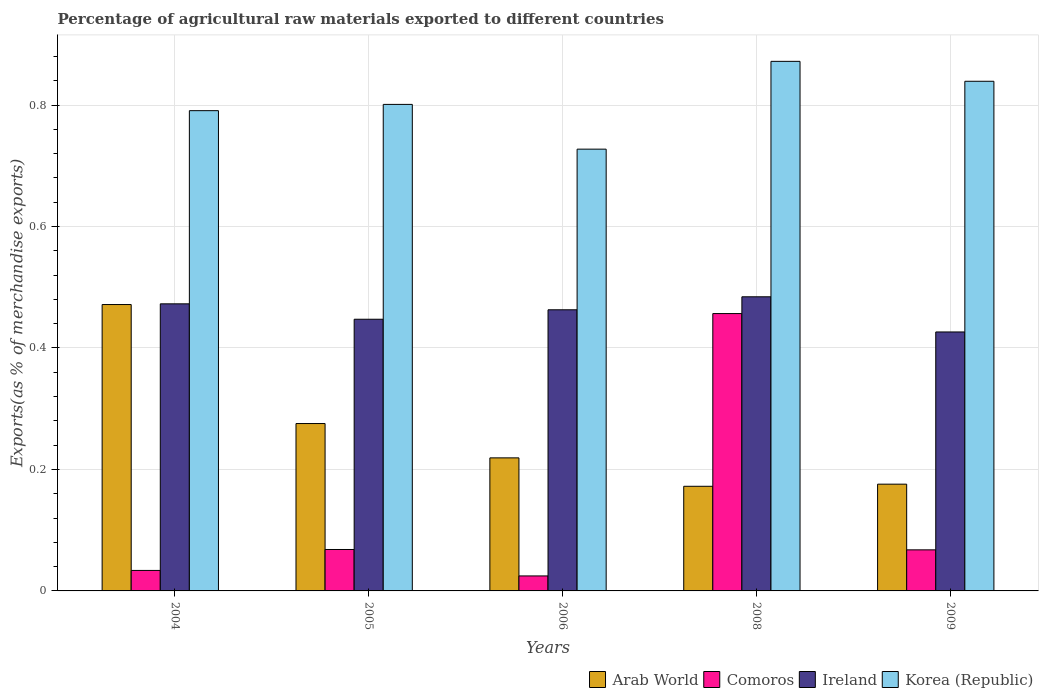How many groups of bars are there?
Give a very brief answer. 5. Are the number of bars on each tick of the X-axis equal?
Offer a terse response. Yes. How many bars are there on the 2nd tick from the left?
Ensure brevity in your answer.  4. What is the label of the 1st group of bars from the left?
Make the answer very short. 2004. What is the percentage of exports to different countries in Arab World in 2005?
Make the answer very short. 0.28. Across all years, what is the maximum percentage of exports to different countries in Ireland?
Offer a very short reply. 0.48. Across all years, what is the minimum percentage of exports to different countries in Korea (Republic)?
Your response must be concise. 0.73. What is the total percentage of exports to different countries in Arab World in the graph?
Give a very brief answer. 1.31. What is the difference between the percentage of exports to different countries in Ireland in 2004 and that in 2005?
Keep it short and to the point. 0.03. What is the difference between the percentage of exports to different countries in Ireland in 2008 and the percentage of exports to different countries in Korea (Republic) in 2009?
Your answer should be very brief. -0.35. What is the average percentage of exports to different countries in Comoros per year?
Your answer should be very brief. 0.13. In the year 2009, what is the difference between the percentage of exports to different countries in Ireland and percentage of exports to different countries in Comoros?
Provide a succinct answer. 0.36. In how many years, is the percentage of exports to different countries in Ireland greater than 0.6400000000000001 %?
Your answer should be compact. 0. What is the ratio of the percentage of exports to different countries in Korea (Republic) in 2005 to that in 2008?
Make the answer very short. 0.92. What is the difference between the highest and the second highest percentage of exports to different countries in Ireland?
Your answer should be compact. 0.01. What is the difference between the highest and the lowest percentage of exports to different countries in Comoros?
Your answer should be very brief. 0.43. In how many years, is the percentage of exports to different countries in Ireland greater than the average percentage of exports to different countries in Ireland taken over all years?
Make the answer very short. 3. What does the 1st bar from the left in 2006 represents?
Offer a very short reply. Arab World. What does the 2nd bar from the right in 2005 represents?
Give a very brief answer. Ireland. How many years are there in the graph?
Provide a succinct answer. 5. Are the values on the major ticks of Y-axis written in scientific E-notation?
Keep it short and to the point. No. Does the graph contain any zero values?
Make the answer very short. No. Does the graph contain grids?
Provide a short and direct response. Yes. How many legend labels are there?
Ensure brevity in your answer.  4. What is the title of the graph?
Your response must be concise. Percentage of agricultural raw materials exported to different countries. What is the label or title of the X-axis?
Your answer should be compact. Years. What is the label or title of the Y-axis?
Your response must be concise. Exports(as % of merchandise exports). What is the Exports(as % of merchandise exports) of Arab World in 2004?
Keep it short and to the point. 0.47. What is the Exports(as % of merchandise exports) of Comoros in 2004?
Provide a short and direct response. 0.03. What is the Exports(as % of merchandise exports) of Ireland in 2004?
Your response must be concise. 0.47. What is the Exports(as % of merchandise exports) of Korea (Republic) in 2004?
Your answer should be compact. 0.79. What is the Exports(as % of merchandise exports) of Arab World in 2005?
Provide a short and direct response. 0.28. What is the Exports(as % of merchandise exports) in Comoros in 2005?
Keep it short and to the point. 0.07. What is the Exports(as % of merchandise exports) of Ireland in 2005?
Ensure brevity in your answer.  0.45. What is the Exports(as % of merchandise exports) in Korea (Republic) in 2005?
Make the answer very short. 0.8. What is the Exports(as % of merchandise exports) of Arab World in 2006?
Ensure brevity in your answer.  0.22. What is the Exports(as % of merchandise exports) of Comoros in 2006?
Your answer should be compact. 0.02. What is the Exports(as % of merchandise exports) of Ireland in 2006?
Your answer should be compact. 0.46. What is the Exports(as % of merchandise exports) in Korea (Republic) in 2006?
Offer a terse response. 0.73. What is the Exports(as % of merchandise exports) of Arab World in 2008?
Provide a short and direct response. 0.17. What is the Exports(as % of merchandise exports) of Comoros in 2008?
Offer a very short reply. 0.46. What is the Exports(as % of merchandise exports) of Ireland in 2008?
Give a very brief answer. 0.48. What is the Exports(as % of merchandise exports) of Korea (Republic) in 2008?
Ensure brevity in your answer.  0.87. What is the Exports(as % of merchandise exports) in Arab World in 2009?
Provide a succinct answer. 0.18. What is the Exports(as % of merchandise exports) in Comoros in 2009?
Provide a succinct answer. 0.07. What is the Exports(as % of merchandise exports) in Ireland in 2009?
Your response must be concise. 0.43. What is the Exports(as % of merchandise exports) in Korea (Republic) in 2009?
Make the answer very short. 0.84. Across all years, what is the maximum Exports(as % of merchandise exports) of Arab World?
Your response must be concise. 0.47. Across all years, what is the maximum Exports(as % of merchandise exports) of Comoros?
Provide a succinct answer. 0.46. Across all years, what is the maximum Exports(as % of merchandise exports) in Ireland?
Ensure brevity in your answer.  0.48. Across all years, what is the maximum Exports(as % of merchandise exports) in Korea (Republic)?
Keep it short and to the point. 0.87. Across all years, what is the minimum Exports(as % of merchandise exports) of Arab World?
Make the answer very short. 0.17. Across all years, what is the minimum Exports(as % of merchandise exports) in Comoros?
Keep it short and to the point. 0.02. Across all years, what is the minimum Exports(as % of merchandise exports) in Ireland?
Give a very brief answer. 0.43. Across all years, what is the minimum Exports(as % of merchandise exports) of Korea (Republic)?
Keep it short and to the point. 0.73. What is the total Exports(as % of merchandise exports) in Arab World in the graph?
Keep it short and to the point. 1.31. What is the total Exports(as % of merchandise exports) in Comoros in the graph?
Your answer should be compact. 0.65. What is the total Exports(as % of merchandise exports) in Ireland in the graph?
Your answer should be very brief. 2.29. What is the total Exports(as % of merchandise exports) in Korea (Republic) in the graph?
Ensure brevity in your answer.  4.03. What is the difference between the Exports(as % of merchandise exports) in Arab World in 2004 and that in 2005?
Ensure brevity in your answer.  0.2. What is the difference between the Exports(as % of merchandise exports) of Comoros in 2004 and that in 2005?
Offer a terse response. -0.03. What is the difference between the Exports(as % of merchandise exports) in Ireland in 2004 and that in 2005?
Your answer should be compact. 0.03. What is the difference between the Exports(as % of merchandise exports) of Korea (Republic) in 2004 and that in 2005?
Your answer should be compact. -0.01. What is the difference between the Exports(as % of merchandise exports) in Arab World in 2004 and that in 2006?
Provide a short and direct response. 0.25. What is the difference between the Exports(as % of merchandise exports) of Comoros in 2004 and that in 2006?
Your answer should be very brief. 0.01. What is the difference between the Exports(as % of merchandise exports) of Ireland in 2004 and that in 2006?
Provide a short and direct response. 0.01. What is the difference between the Exports(as % of merchandise exports) in Korea (Republic) in 2004 and that in 2006?
Keep it short and to the point. 0.06. What is the difference between the Exports(as % of merchandise exports) in Arab World in 2004 and that in 2008?
Provide a short and direct response. 0.3. What is the difference between the Exports(as % of merchandise exports) in Comoros in 2004 and that in 2008?
Your answer should be compact. -0.42. What is the difference between the Exports(as % of merchandise exports) of Ireland in 2004 and that in 2008?
Give a very brief answer. -0.01. What is the difference between the Exports(as % of merchandise exports) of Korea (Republic) in 2004 and that in 2008?
Your answer should be compact. -0.08. What is the difference between the Exports(as % of merchandise exports) of Arab World in 2004 and that in 2009?
Your answer should be compact. 0.3. What is the difference between the Exports(as % of merchandise exports) of Comoros in 2004 and that in 2009?
Your response must be concise. -0.03. What is the difference between the Exports(as % of merchandise exports) in Ireland in 2004 and that in 2009?
Provide a succinct answer. 0.05. What is the difference between the Exports(as % of merchandise exports) in Korea (Republic) in 2004 and that in 2009?
Provide a succinct answer. -0.05. What is the difference between the Exports(as % of merchandise exports) in Arab World in 2005 and that in 2006?
Your answer should be compact. 0.06. What is the difference between the Exports(as % of merchandise exports) of Comoros in 2005 and that in 2006?
Make the answer very short. 0.04. What is the difference between the Exports(as % of merchandise exports) of Ireland in 2005 and that in 2006?
Offer a terse response. -0.02. What is the difference between the Exports(as % of merchandise exports) in Korea (Republic) in 2005 and that in 2006?
Offer a very short reply. 0.07. What is the difference between the Exports(as % of merchandise exports) in Arab World in 2005 and that in 2008?
Provide a short and direct response. 0.1. What is the difference between the Exports(as % of merchandise exports) in Comoros in 2005 and that in 2008?
Your answer should be compact. -0.39. What is the difference between the Exports(as % of merchandise exports) in Ireland in 2005 and that in 2008?
Provide a succinct answer. -0.04. What is the difference between the Exports(as % of merchandise exports) in Korea (Republic) in 2005 and that in 2008?
Provide a short and direct response. -0.07. What is the difference between the Exports(as % of merchandise exports) of Arab World in 2005 and that in 2009?
Ensure brevity in your answer.  0.1. What is the difference between the Exports(as % of merchandise exports) in Comoros in 2005 and that in 2009?
Ensure brevity in your answer.  0. What is the difference between the Exports(as % of merchandise exports) in Ireland in 2005 and that in 2009?
Your response must be concise. 0.02. What is the difference between the Exports(as % of merchandise exports) of Korea (Republic) in 2005 and that in 2009?
Provide a short and direct response. -0.04. What is the difference between the Exports(as % of merchandise exports) of Arab World in 2006 and that in 2008?
Ensure brevity in your answer.  0.05. What is the difference between the Exports(as % of merchandise exports) of Comoros in 2006 and that in 2008?
Your answer should be compact. -0.43. What is the difference between the Exports(as % of merchandise exports) in Ireland in 2006 and that in 2008?
Give a very brief answer. -0.02. What is the difference between the Exports(as % of merchandise exports) in Korea (Republic) in 2006 and that in 2008?
Provide a short and direct response. -0.14. What is the difference between the Exports(as % of merchandise exports) in Arab World in 2006 and that in 2009?
Provide a short and direct response. 0.04. What is the difference between the Exports(as % of merchandise exports) of Comoros in 2006 and that in 2009?
Your answer should be compact. -0.04. What is the difference between the Exports(as % of merchandise exports) in Ireland in 2006 and that in 2009?
Your response must be concise. 0.04. What is the difference between the Exports(as % of merchandise exports) of Korea (Republic) in 2006 and that in 2009?
Your answer should be compact. -0.11. What is the difference between the Exports(as % of merchandise exports) of Arab World in 2008 and that in 2009?
Provide a succinct answer. -0. What is the difference between the Exports(as % of merchandise exports) of Comoros in 2008 and that in 2009?
Your response must be concise. 0.39. What is the difference between the Exports(as % of merchandise exports) in Ireland in 2008 and that in 2009?
Give a very brief answer. 0.06. What is the difference between the Exports(as % of merchandise exports) in Korea (Republic) in 2008 and that in 2009?
Your answer should be very brief. 0.03. What is the difference between the Exports(as % of merchandise exports) in Arab World in 2004 and the Exports(as % of merchandise exports) in Comoros in 2005?
Keep it short and to the point. 0.4. What is the difference between the Exports(as % of merchandise exports) in Arab World in 2004 and the Exports(as % of merchandise exports) in Ireland in 2005?
Your answer should be very brief. 0.02. What is the difference between the Exports(as % of merchandise exports) of Arab World in 2004 and the Exports(as % of merchandise exports) of Korea (Republic) in 2005?
Provide a short and direct response. -0.33. What is the difference between the Exports(as % of merchandise exports) of Comoros in 2004 and the Exports(as % of merchandise exports) of Ireland in 2005?
Provide a succinct answer. -0.41. What is the difference between the Exports(as % of merchandise exports) in Comoros in 2004 and the Exports(as % of merchandise exports) in Korea (Republic) in 2005?
Offer a terse response. -0.77. What is the difference between the Exports(as % of merchandise exports) in Ireland in 2004 and the Exports(as % of merchandise exports) in Korea (Republic) in 2005?
Your answer should be compact. -0.33. What is the difference between the Exports(as % of merchandise exports) in Arab World in 2004 and the Exports(as % of merchandise exports) in Comoros in 2006?
Your answer should be compact. 0.45. What is the difference between the Exports(as % of merchandise exports) in Arab World in 2004 and the Exports(as % of merchandise exports) in Ireland in 2006?
Offer a terse response. 0.01. What is the difference between the Exports(as % of merchandise exports) in Arab World in 2004 and the Exports(as % of merchandise exports) in Korea (Republic) in 2006?
Ensure brevity in your answer.  -0.26. What is the difference between the Exports(as % of merchandise exports) of Comoros in 2004 and the Exports(as % of merchandise exports) of Ireland in 2006?
Provide a succinct answer. -0.43. What is the difference between the Exports(as % of merchandise exports) in Comoros in 2004 and the Exports(as % of merchandise exports) in Korea (Republic) in 2006?
Keep it short and to the point. -0.69. What is the difference between the Exports(as % of merchandise exports) of Ireland in 2004 and the Exports(as % of merchandise exports) of Korea (Republic) in 2006?
Provide a short and direct response. -0.25. What is the difference between the Exports(as % of merchandise exports) of Arab World in 2004 and the Exports(as % of merchandise exports) of Comoros in 2008?
Offer a very short reply. 0.01. What is the difference between the Exports(as % of merchandise exports) in Arab World in 2004 and the Exports(as % of merchandise exports) in Ireland in 2008?
Your answer should be compact. -0.01. What is the difference between the Exports(as % of merchandise exports) of Arab World in 2004 and the Exports(as % of merchandise exports) of Korea (Republic) in 2008?
Provide a succinct answer. -0.4. What is the difference between the Exports(as % of merchandise exports) in Comoros in 2004 and the Exports(as % of merchandise exports) in Ireland in 2008?
Your answer should be compact. -0.45. What is the difference between the Exports(as % of merchandise exports) in Comoros in 2004 and the Exports(as % of merchandise exports) in Korea (Republic) in 2008?
Provide a succinct answer. -0.84. What is the difference between the Exports(as % of merchandise exports) of Ireland in 2004 and the Exports(as % of merchandise exports) of Korea (Republic) in 2008?
Ensure brevity in your answer.  -0.4. What is the difference between the Exports(as % of merchandise exports) of Arab World in 2004 and the Exports(as % of merchandise exports) of Comoros in 2009?
Offer a very short reply. 0.4. What is the difference between the Exports(as % of merchandise exports) in Arab World in 2004 and the Exports(as % of merchandise exports) in Ireland in 2009?
Your answer should be very brief. 0.05. What is the difference between the Exports(as % of merchandise exports) of Arab World in 2004 and the Exports(as % of merchandise exports) of Korea (Republic) in 2009?
Offer a terse response. -0.37. What is the difference between the Exports(as % of merchandise exports) in Comoros in 2004 and the Exports(as % of merchandise exports) in Ireland in 2009?
Give a very brief answer. -0.39. What is the difference between the Exports(as % of merchandise exports) of Comoros in 2004 and the Exports(as % of merchandise exports) of Korea (Republic) in 2009?
Give a very brief answer. -0.81. What is the difference between the Exports(as % of merchandise exports) of Ireland in 2004 and the Exports(as % of merchandise exports) of Korea (Republic) in 2009?
Ensure brevity in your answer.  -0.37. What is the difference between the Exports(as % of merchandise exports) in Arab World in 2005 and the Exports(as % of merchandise exports) in Comoros in 2006?
Offer a terse response. 0.25. What is the difference between the Exports(as % of merchandise exports) in Arab World in 2005 and the Exports(as % of merchandise exports) in Ireland in 2006?
Provide a succinct answer. -0.19. What is the difference between the Exports(as % of merchandise exports) in Arab World in 2005 and the Exports(as % of merchandise exports) in Korea (Republic) in 2006?
Your answer should be compact. -0.45. What is the difference between the Exports(as % of merchandise exports) of Comoros in 2005 and the Exports(as % of merchandise exports) of Ireland in 2006?
Your response must be concise. -0.39. What is the difference between the Exports(as % of merchandise exports) of Comoros in 2005 and the Exports(as % of merchandise exports) of Korea (Republic) in 2006?
Give a very brief answer. -0.66. What is the difference between the Exports(as % of merchandise exports) of Ireland in 2005 and the Exports(as % of merchandise exports) of Korea (Republic) in 2006?
Your answer should be very brief. -0.28. What is the difference between the Exports(as % of merchandise exports) in Arab World in 2005 and the Exports(as % of merchandise exports) in Comoros in 2008?
Provide a short and direct response. -0.18. What is the difference between the Exports(as % of merchandise exports) of Arab World in 2005 and the Exports(as % of merchandise exports) of Ireland in 2008?
Give a very brief answer. -0.21. What is the difference between the Exports(as % of merchandise exports) of Arab World in 2005 and the Exports(as % of merchandise exports) of Korea (Republic) in 2008?
Your answer should be very brief. -0.6. What is the difference between the Exports(as % of merchandise exports) in Comoros in 2005 and the Exports(as % of merchandise exports) in Ireland in 2008?
Offer a very short reply. -0.42. What is the difference between the Exports(as % of merchandise exports) in Comoros in 2005 and the Exports(as % of merchandise exports) in Korea (Republic) in 2008?
Your response must be concise. -0.8. What is the difference between the Exports(as % of merchandise exports) of Ireland in 2005 and the Exports(as % of merchandise exports) of Korea (Republic) in 2008?
Offer a very short reply. -0.42. What is the difference between the Exports(as % of merchandise exports) of Arab World in 2005 and the Exports(as % of merchandise exports) of Comoros in 2009?
Provide a short and direct response. 0.21. What is the difference between the Exports(as % of merchandise exports) of Arab World in 2005 and the Exports(as % of merchandise exports) of Ireland in 2009?
Keep it short and to the point. -0.15. What is the difference between the Exports(as % of merchandise exports) of Arab World in 2005 and the Exports(as % of merchandise exports) of Korea (Republic) in 2009?
Give a very brief answer. -0.56. What is the difference between the Exports(as % of merchandise exports) in Comoros in 2005 and the Exports(as % of merchandise exports) in Ireland in 2009?
Give a very brief answer. -0.36. What is the difference between the Exports(as % of merchandise exports) of Comoros in 2005 and the Exports(as % of merchandise exports) of Korea (Republic) in 2009?
Give a very brief answer. -0.77. What is the difference between the Exports(as % of merchandise exports) in Ireland in 2005 and the Exports(as % of merchandise exports) in Korea (Republic) in 2009?
Make the answer very short. -0.39. What is the difference between the Exports(as % of merchandise exports) of Arab World in 2006 and the Exports(as % of merchandise exports) of Comoros in 2008?
Give a very brief answer. -0.24. What is the difference between the Exports(as % of merchandise exports) in Arab World in 2006 and the Exports(as % of merchandise exports) in Ireland in 2008?
Offer a terse response. -0.27. What is the difference between the Exports(as % of merchandise exports) in Arab World in 2006 and the Exports(as % of merchandise exports) in Korea (Republic) in 2008?
Your answer should be compact. -0.65. What is the difference between the Exports(as % of merchandise exports) in Comoros in 2006 and the Exports(as % of merchandise exports) in Ireland in 2008?
Provide a succinct answer. -0.46. What is the difference between the Exports(as % of merchandise exports) in Comoros in 2006 and the Exports(as % of merchandise exports) in Korea (Republic) in 2008?
Give a very brief answer. -0.85. What is the difference between the Exports(as % of merchandise exports) in Ireland in 2006 and the Exports(as % of merchandise exports) in Korea (Republic) in 2008?
Your answer should be very brief. -0.41. What is the difference between the Exports(as % of merchandise exports) in Arab World in 2006 and the Exports(as % of merchandise exports) in Comoros in 2009?
Offer a very short reply. 0.15. What is the difference between the Exports(as % of merchandise exports) of Arab World in 2006 and the Exports(as % of merchandise exports) of Ireland in 2009?
Your answer should be compact. -0.21. What is the difference between the Exports(as % of merchandise exports) of Arab World in 2006 and the Exports(as % of merchandise exports) of Korea (Republic) in 2009?
Keep it short and to the point. -0.62. What is the difference between the Exports(as % of merchandise exports) in Comoros in 2006 and the Exports(as % of merchandise exports) in Ireland in 2009?
Your answer should be very brief. -0.4. What is the difference between the Exports(as % of merchandise exports) in Comoros in 2006 and the Exports(as % of merchandise exports) in Korea (Republic) in 2009?
Offer a terse response. -0.81. What is the difference between the Exports(as % of merchandise exports) of Ireland in 2006 and the Exports(as % of merchandise exports) of Korea (Republic) in 2009?
Provide a short and direct response. -0.38. What is the difference between the Exports(as % of merchandise exports) in Arab World in 2008 and the Exports(as % of merchandise exports) in Comoros in 2009?
Your answer should be compact. 0.1. What is the difference between the Exports(as % of merchandise exports) in Arab World in 2008 and the Exports(as % of merchandise exports) in Ireland in 2009?
Keep it short and to the point. -0.25. What is the difference between the Exports(as % of merchandise exports) in Arab World in 2008 and the Exports(as % of merchandise exports) in Korea (Republic) in 2009?
Provide a short and direct response. -0.67. What is the difference between the Exports(as % of merchandise exports) of Comoros in 2008 and the Exports(as % of merchandise exports) of Ireland in 2009?
Ensure brevity in your answer.  0.03. What is the difference between the Exports(as % of merchandise exports) in Comoros in 2008 and the Exports(as % of merchandise exports) in Korea (Republic) in 2009?
Offer a very short reply. -0.38. What is the difference between the Exports(as % of merchandise exports) in Ireland in 2008 and the Exports(as % of merchandise exports) in Korea (Republic) in 2009?
Your answer should be very brief. -0.35. What is the average Exports(as % of merchandise exports) of Arab World per year?
Your response must be concise. 0.26. What is the average Exports(as % of merchandise exports) of Comoros per year?
Keep it short and to the point. 0.13. What is the average Exports(as % of merchandise exports) in Ireland per year?
Keep it short and to the point. 0.46. What is the average Exports(as % of merchandise exports) in Korea (Republic) per year?
Give a very brief answer. 0.81. In the year 2004, what is the difference between the Exports(as % of merchandise exports) in Arab World and Exports(as % of merchandise exports) in Comoros?
Give a very brief answer. 0.44. In the year 2004, what is the difference between the Exports(as % of merchandise exports) of Arab World and Exports(as % of merchandise exports) of Ireland?
Ensure brevity in your answer.  -0. In the year 2004, what is the difference between the Exports(as % of merchandise exports) in Arab World and Exports(as % of merchandise exports) in Korea (Republic)?
Provide a short and direct response. -0.32. In the year 2004, what is the difference between the Exports(as % of merchandise exports) of Comoros and Exports(as % of merchandise exports) of Ireland?
Ensure brevity in your answer.  -0.44. In the year 2004, what is the difference between the Exports(as % of merchandise exports) in Comoros and Exports(as % of merchandise exports) in Korea (Republic)?
Your answer should be very brief. -0.76. In the year 2004, what is the difference between the Exports(as % of merchandise exports) of Ireland and Exports(as % of merchandise exports) of Korea (Republic)?
Provide a succinct answer. -0.32. In the year 2005, what is the difference between the Exports(as % of merchandise exports) in Arab World and Exports(as % of merchandise exports) in Comoros?
Offer a terse response. 0.21. In the year 2005, what is the difference between the Exports(as % of merchandise exports) in Arab World and Exports(as % of merchandise exports) in Ireland?
Offer a very short reply. -0.17. In the year 2005, what is the difference between the Exports(as % of merchandise exports) of Arab World and Exports(as % of merchandise exports) of Korea (Republic)?
Your answer should be compact. -0.53. In the year 2005, what is the difference between the Exports(as % of merchandise exports) in Comoros and Exports(as % of merchandise exports) in Ireland?
Offer a very short reply. -0.38. In the year 2005, what is the difference between the Exports(as % of merchandise exports) of Comoros and Exports(as % of merchandise exports) of Korea (Republic)?
Provide a succinct answer. -0.73. In the year 2005, what is the difference between the Exports(as % of merchandise exports) in Ireland and Exports(as % of merchandise exports) in Korea (Republic)?
Offer a terse response. -0.35. In the year 2006, what is the difference between the Exports(as % of merchandise exports) of Arab World and Exports(as % of merchandise exports) of Comoros?
Your answer should be compact. 0.19. In the year 2006, what is the difference between the Exports(as % of merchandise exports) in Arab World and Exports(as % of merchandise exports) in Ireland?
Offer a terse response. -0.24. In the year 2006, what is the difference between the Exports(as % of merchandise exports) in Arab World and Exports(as % of merchandise exports) in Korea (Republic)?
Offer a terse response. -0.51. In the year 2006, what is the difference between the Exports(as % of merchandise exports) in Comoros and Exports(as % of merchandise exports) in Ireland?
Offer a very short reply. -0.44. In the year 2006, what is the difference between the Exports(as % of merchandise exports) in Comoros and Exports(as % of merchandise exports) in Korea (Republic)?
Provide a short and direct response. -0.7. In the year 2006, what is the difference between the Exports(as % of merchandise exports) in Ireland and Exports(as % of merchandise exports) in Korea (Republic)?
Give a very brief answer. -0.26. In the year 2008, what is the difference between the Exports(as % of merchandise exports) of Arab World and Exports(as % of merchandise exports) of Comoros?
Your answer should be compact. -0.28. In the year 2008, what is the difference between the Exports(as % of merchandise exports) of Arab World and Exports(as % of merchandise exports) of Ireland?
Provide a short and direct response. -0.31. In the year 2008, what is the difference between the Exports(as % of merchandise exports) in Arab World and Exports(as % of merchandise exports) in Korea (Republic)?
Keep it short and to the point. -0.7. In the year 2008, what is the difference between the Exports(as % of merchandise exports) in Comoros and Exports(as % of merchandise exports) in Ireland?
Your answer should be very brief. -0.03. In the year 2008, what is the difference between the Exports(as % of merchandise exports) in Comoros and Exports(as % of merchandise exports) in Korea (Republic)?
Offer a very short reply. -0.42. In the year 2008, what is the difference between the Exports(as % of merchandise exports) in Ireland and Exports(as % of merchandise exports) in Korea (Republic)?
Make the answer very short. -0.39. In the year 2009, what is the difference between the Exports(as % of merchandise exports) in Arab World and Exports(as % of merchandise exports) in Comoros?
Offer a very short reply. 0.11. In the year 2009, what is the difference between the Exports(as % of merchandise exports) in Arab World and Exports(as % of merchandise exports) in Ireland?
Provide a short and direct response. -0.25. In the year 2009, what is the difference between the Exports(as % of merchandise exports) of Arab World and Exports(as % of merchandise exports) of Korea (Republic)?
Make the answer very short. -0.66. In the year 2009, what is the difference between the Exports(as % of merchandise exports) of Comoros and Exports(as % of merchandise exports) of Ireland?
Provide a succinct answer. -0.36. In the year 2009, what is the difference between the Exports(as % of merchandise exports) of Comoros and Exports(as % of merchandise exports) of Korea (Republic)?
Provide a succinct answer. -0.77. In the year 2009, what is the difference between the Exports(as % of merchandise exports) in Ireland and Exports(as % of merchandise exports) in Korea (Republic)?
Give a very brief answer. -0.41. What is the ratio of the Exports(as % of merchandise exports) of Arab World in 2004 to that in 2005?
Provide a short and direct response. 1.71. What is the ratio of the Exports(as % of merchandise exports) in Comoros in 2004 to that in 2005?
Provide a succinct answer. 0.49. What is the ratio of the Exports(as % of merchandise exports) in Ireland in 2004 to that in 2005?
Ensure brevity in your answer.  1.06. What is the ratio of the Exports(as % of merchandise exports) in Korea (Republic) in 2004 to that in 2005?
Give a very brief answer. 0.99. What is the ratio of the Exports(as % of merchandise exports) in Arab World in 2004 to that in 2006?
Provide a short and direct response. 2.15. What is the ratio of the Exports(as % of merchandise exports) of Comoros in 2004 to that in 2006?
Give a very brief answer. 1.37. What is the ratio of the Exports(as % of merchandise exports) of Ireland in 2004 to that in 2006?
Your answer should be compact. 1.02. What is the ratio of the Exports(as % of merchandise exports) in Korea (Republic) in 2004 to that in 2006?
Provide a succinct answer. 1.09. What is the ratio of the Exports(as % of merchandise exports) in Arab World in 2004 to that in 2008?
Provide a short and direct response. 2.74. What is the ratio of the Exports(as % of merchandise exports) of Comoros in 2004 to that in 2008?
Provide a succinct answer. 0.07. What is the ratio of the Exports(as % of merchandise exports) of Ireland in 2004 to that in 2008?
Your answer should be very brief. 0.98. What is the ratio of the Exports(as % of merchandise exports) of Korea (Republic) in 2004 to that in 2008?
Your answer should be very brief. 0.91. What is the ratio of the Exports(as % of merchandise exports) in Arab World in 2004 to that in 2009?
Ensure brevity in your answer.  2.68. What is the ratio of the Exports(as % of merchandise exports) of Comoros in 2004 to that in 2009?
Give a very brief answer. 0.5. What is the ratio of the Exports(as % of merchandise exports) in Ireland in 2004 to that in 2009?
Make the answer very short. 1.11. What is the ratio of the Exports(as % of merchandise exports) in Korea (Republic) in 2004 to that in 2009?
Your answer should be very brief. 0.94. What is the ratio of the Exports(as % of merchandise exports) of Arab World in 2005 to that in 2006?
Give a very brief answer. 1.26. What is the ratio of the Exports(as % of merchandise exports) in Comoros in 2005 to that in 2006?
Your response must be concise. 2.76. What is the ratio of the Exports(as % of merchandise exports) of Ireland in 2005 to that in 2006?
Offer a terse response. 0.97. What is the ratio of the Exports(as % of merchandise exports) of Korea (Republic) in 2005 to that in 2006?
Your response must be concise. 1.1. What is the ratio of the Exports(as % of merchandise exports) in Arab World in 2005 to that in 2008?
Your answer should be very brief. 1.6. What is the ratio of the Exports(as % of merchandise exports) of Comoros in 2005 to that in 2008?
Ensure brevity in your answer.  0.15. What is the ratio of the Exports(as % of merchandise exports) of Ireland in 2005 to that in 2008?
Your response must be concise. 0.92. What is the ratio of the Exports(as % of merchandise exports) of Korea (Republic) in 2005 to that in 2008?
Your answer should be very brief. 0.92. What is the ratio of the Exports(as % of merchandise exports) in Arab World in 2005 to that in 2009?
Make the answer very short. 1.57. What is the ratio of the Exports(as % of merchandise exports) in Comoros in 2005 to that in 2009?
Provide a succinct answer. 1.01. What is the ratio of the Exports(as % of merchandise exports) in Ireland in 2005 to that in 2009?
Your answer should be very brief. 1.05. What is the ratio of the Exports(as % of merchandise exports) of Korea (Republic) in 2005 to that in 2009?
Make the answer very short. 0.95. What is the ratio of the Exports(as % of merchandise exports) in Arab World in 2006 to that in 2008?
Your answer should be compact. 1.27. What is the ratio of the Exports(as % of merchandise exports) in Comoros in 2006 to that in 2008?
Give a very brief answer. 0.05. What is the ratio of the Exports(as % of merchandise exports) in Ireland in 2006 to that in 2008?
Make the answer very short. 0.96. What is the ratio of the Exports(as % of merchandise exports) of Korea (Republic) in 2006 to that in 2008?
Provide a short and direct response. 0.83. What is the ratio of the Exports(as % of merchandise exports) in Arab World in 2006 to that in 2009?
Keep it short and to the point. 1.25. What is the ratio of the Exports(as % of merchandise exports) of Comoros in 2006 to that in 2009?
Provide a short and direct response. 0.37. What is the ratio of the Exports(as % of merchandise exports) of Ireland in 2006 to that in 2009?
Keep it short and to the point. 1.09. What is the ratio of the Exports(as % of merchandise exports) of Korea (Republic) in 2006 to that in 2009?
Provide a succinct answer. 0.87. What is the ratio of the Exports(as % of merchandise exports) in Arab World in 2008 to that in 2009?
Provide a succinct answer. 0.98. What is the ratio of the Exports(as % of merchandise exports) of Comoros in 2008 to that in 2009?
Provide a succinct answer. 6.75. What is the ratio of the Exports(as % of merchandise exports) in Ireland in 2008 to that in 2009?
Ensure brevity in your answer.  1.14. What is the ratio of the Exports(as % of merchandise exports) of Korea (Republic) in 2008 to that in 2009?
Your answer should be very brief. 1.04. What is the difference between the highest and the second highest Exports(as % of merchandise exports) in Arab World?
Provide a short and direct response. 0.2. What is the difference between the highest and the second highest Exports(as % of merchandise exports) of Comoros?
Keep it short and to the point. 0.39. What is the difference between the highest and the second highest Exports(as % of merchandise exports) of Ireland?
Make the answer very short. 0.01. What is the difference between the highest and the second highest Exports(as % of merchandise exports) in Korea (Republic)?
Your response must be concise. 0.03. What is the difference between the highest and the lowest Exports(as % of merchandise exports) in Arab World?
Give a very brief answer. 0.3. What is the difference between the highest and the lowest Exports(as % of merchandise exports) of Comoros?
Make the answer very short. 0.43. What is the difference between the highest and the lowest Exports(as % of merchandise exports) of Ireland?
Your response must be concise. 0.06. What is the difference between the highest and the lowest Exports(as % of merchandise exports) of Korea (Republic)?
Your answer should be compact. 0.14. 